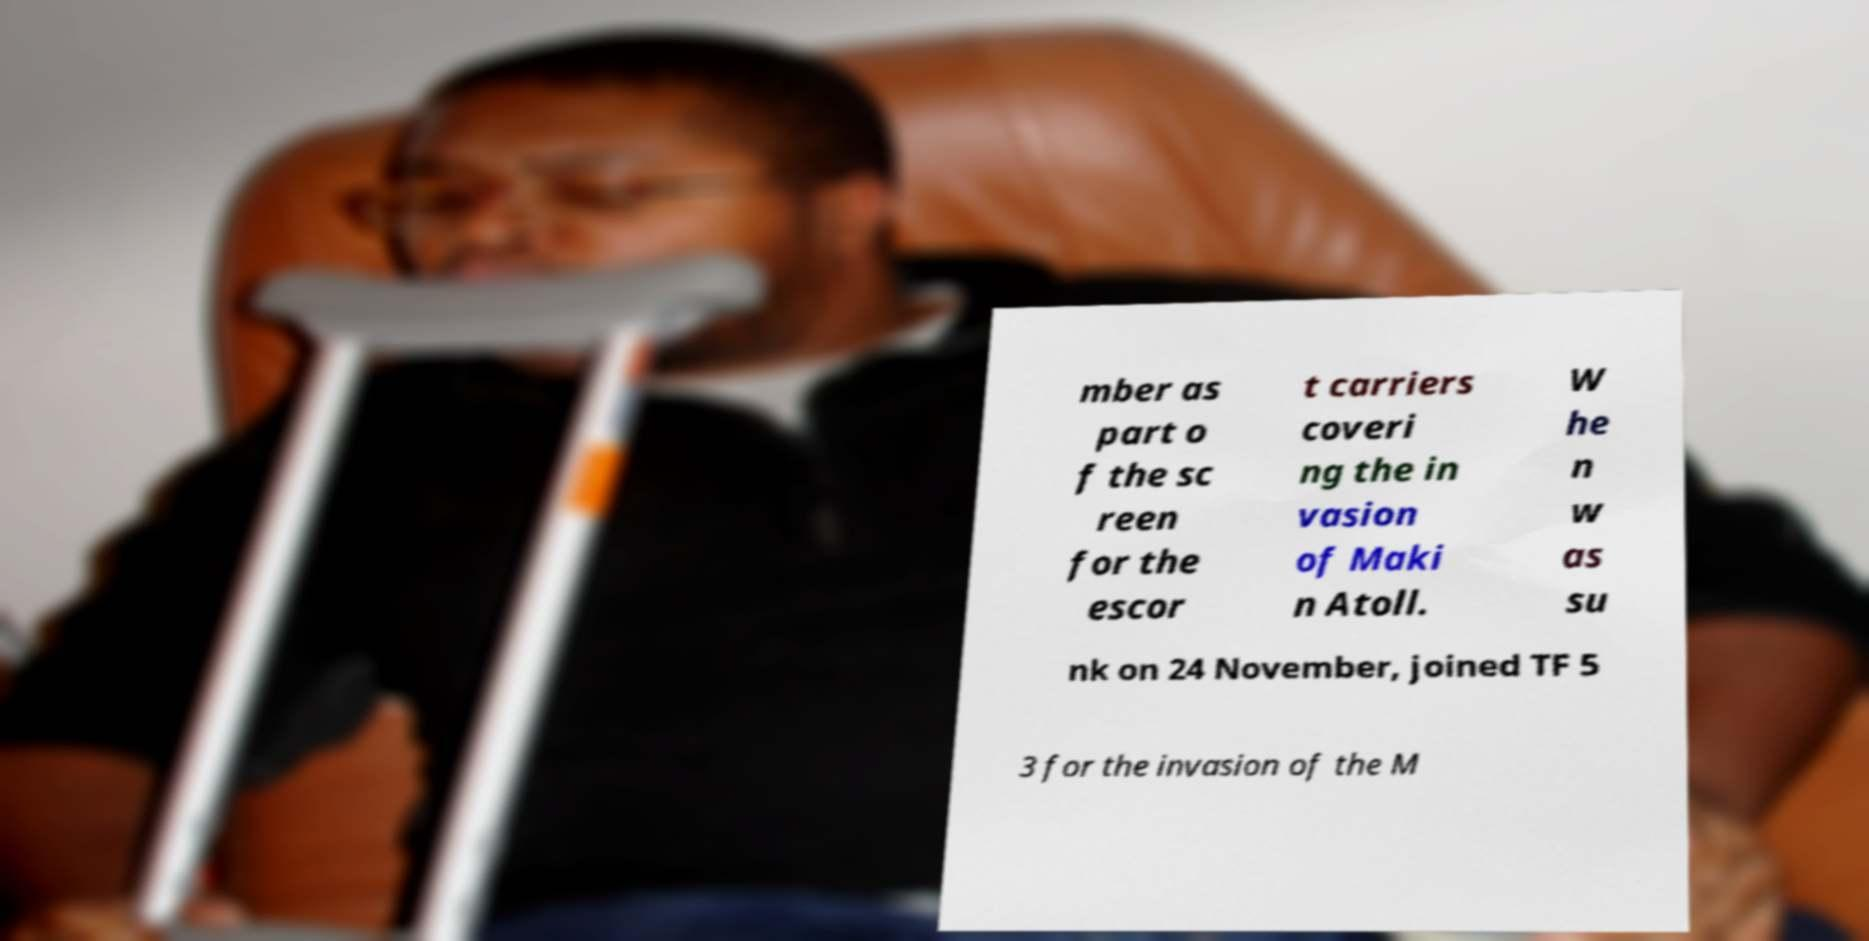Please identify and transcribe the text found in this image. mber as part o f the sc reen for the escor t carriers coveri ng the in vasion of Maki n Atoll. W he n w as su nk on 24 November, joined TF 5 3 for the invasion of the M 